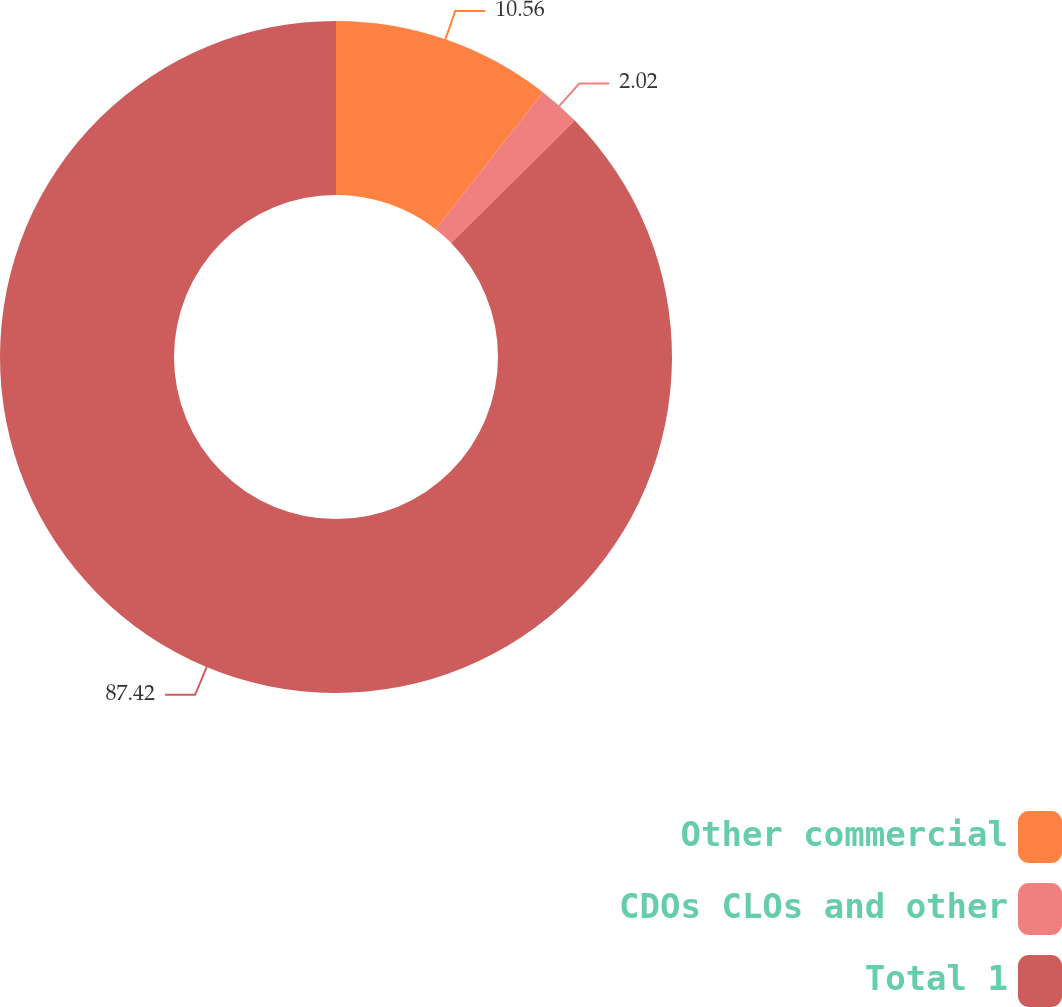Convert chart to OTSL. <chart><loc_0><loc_0><loc_500><loc_500><pie_chart><fcel>Other commercial<fcel>CDOs CLOs and other<fcel>Total 1<nl><fcel>10.56%<fcel>2.02%<fcel>87.42%<nl></chart> 